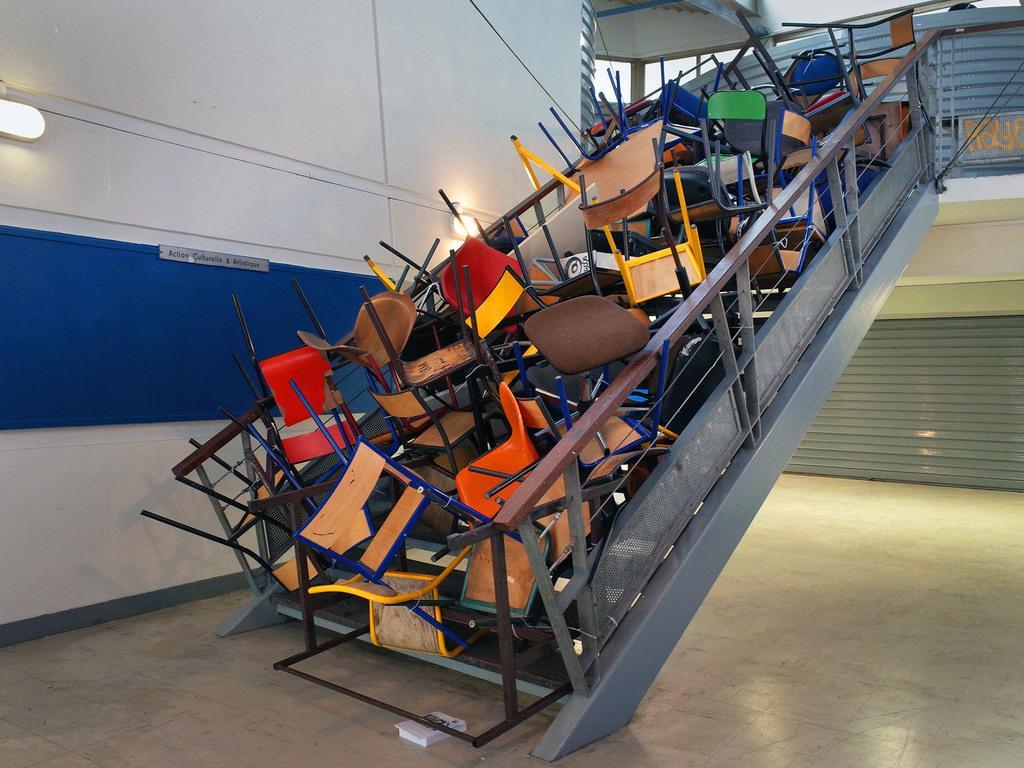Can you describe this image briefly? This image consists of stairs on which there are many chairs made up of wood and plastic. At the bottom, there is a floor. In the background, there is a shutter. To the left, there is a big wall on which a light is fixed. 